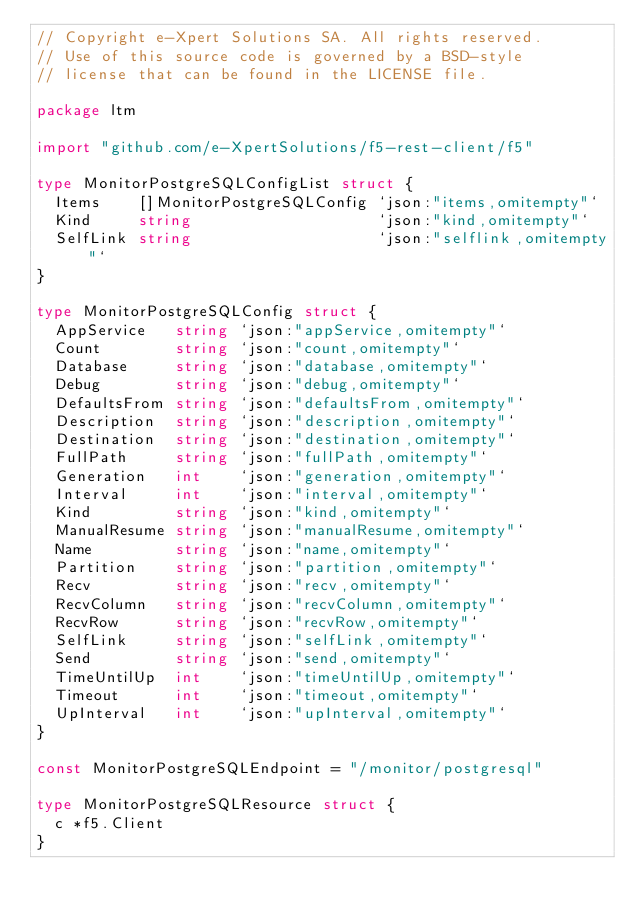<code> <loc_0><loc_0><loc_500><loc_500><_Go_>// Copyright e-Xpert Solutions SA. All rights reserved.
// Use of this source code is governed by a BSD-style
// license that can be found in the LICENSE file.

package ltm

import "github.com/e-XpertSolutions/f5-rest-client/f5"

type MonitorPostgreSQLConfigList struct {
	Items    []MonitorPostgreSQLConfig `json:"items,omitempty"`
	Kind     string                    `json:"kind,omitempty"`
	SelfLink string                    `json:"selflink,omitempty"`
}

type MonitorPostgreSQLConfig struct {
	AppService   string `json:"appService,omitempty"`
	Count        string `json:"count,omitempty"`
	Database     string `json:"database,omitempty"`
	Debug        string `json:"debug,omitempty"`
	DefaultsFrom string `json:"defaultsFrom,omitempty"`
	Description  string `json:"description,omitempty"`
	Destination  string `json:"destination,omitempty"`
	FullPath     string `json:"fullPath,omitempty"`
	Generation   int    `json:"generation,omitempty"`
	Interval     int    `json:"interval,omitempty"`
	Kind         string `json:"kind,omitempty"`
	ManualResume string `json:"manualResume,omitempty"`
	Name         string `json:"name,omitempty"`
	Partition    string `json:"partition,omitempty"`
	Recv         string `json:"recv,omitempty"`
	RecvColumn   string `json:"recvColumn,omitempty"`
	RecvRow      string `json:"recvRow,omitempty"`
	SelfLink     string `json:"selfLink,omitempty"`
	Send         string `json:"send,omitempty"`
	TimeUntilUp  int    `json:"timeUntilUp,omitempty"`
	Timeout      int    `json:"timeout,omitempty"`
	UpInterval   int    `json:"upInterval,omitempty"`
}

const MonitorPostgreSQLEndpoint = "/monitor/postgresql"

type MonitorPostgreSQLResource struct {
	c *f5.Client
}
</code> 